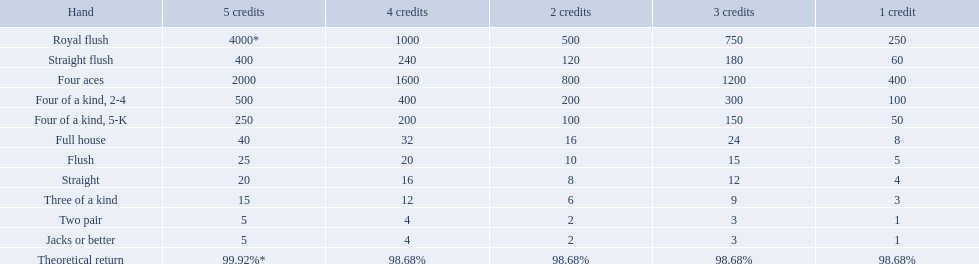What are the hands in super aces? Royal flush, Straight flush, Four aces, Four of a kind, 2-4, Four of a kind, 5-K, Full house, Flush, Straight, Three of a kind, Two pair, Jacks or better. What hand gives the highest credits? Royal flush. What are each of the hands? Royal flush, Straight flush, Four aces, Four of a kind, 2-4, Four of a kind, 5-K, Full house, Flush, Straight, Three of a kind, Two pair, Jacks or better, Theoretical return. Which hand ranks higher between straights and flushes? Flush. What is the values in the 5 credits area? 4000*, 400, 2000, 500, 250, 40, 25, 20, 15, 5, 5. Which of these is for a four of a kind? 500, 250. What is the higher value? 500. What hand is this for Four of a kind, 2-4. 